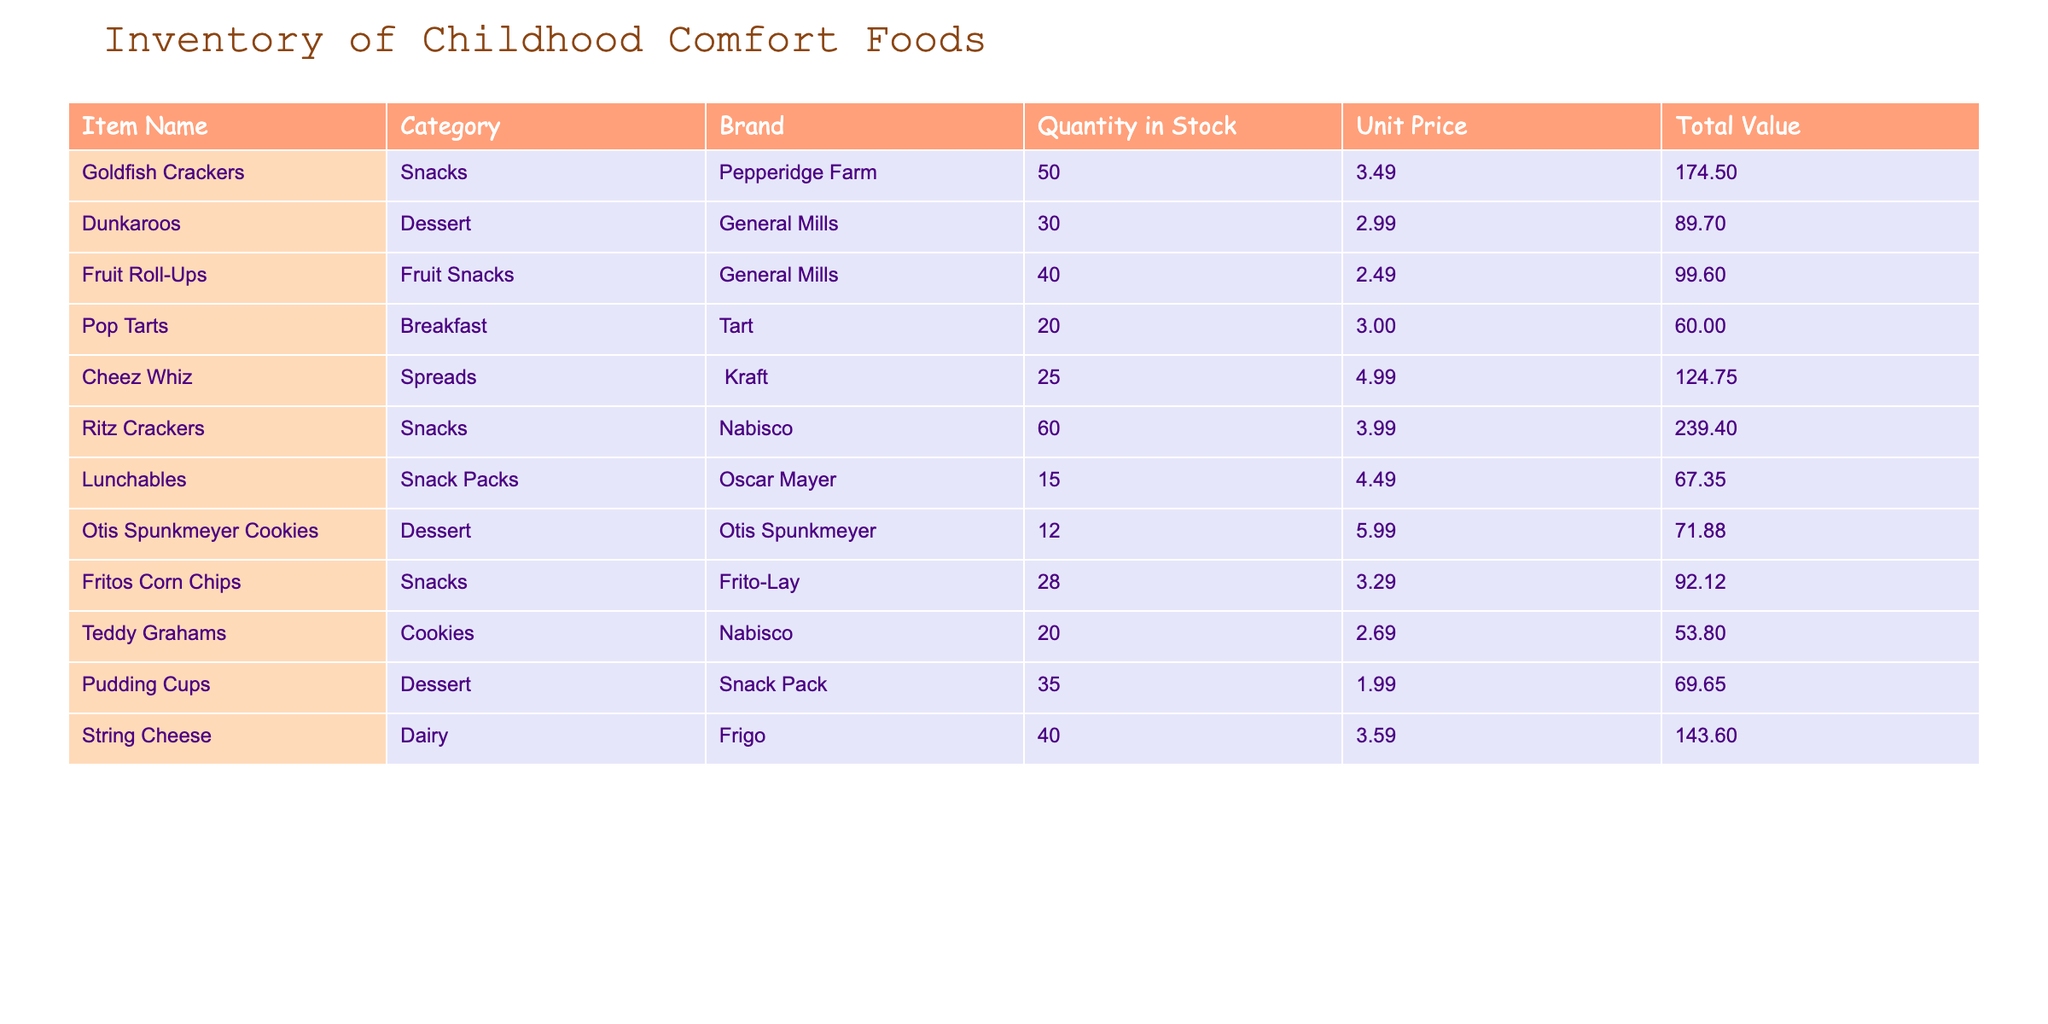What is the total quantity of Goldfish Crackers in stock? The table shows that the quantity of Goldfish Crackers is listed in the "Quantity in Stock" column, which indicates a total of 50 units.
Answer: 50 What is the unit price of Dunkaroos? Referring to the "Unit Price" column for Dunkaroos, the price is shown as $2.99.
Answer: $2.99 Which snacks have a quantity in stock greater than 40? We need to look at the "Quantity in Stock" for each snack. Goldfish Crackers (50), Ritz Crackers (60), Fruit Roll-Ups (40), and Fritos Corn Chips (28) are checked. Only Goldfish Crackers and Ritz Crackers meet the criteria with values over 40.
Answer: Goldfish Crackers, Ritz Crackers What is the total value of all the Dessert items combined? We identify the Dessert items as Dunkaroos, Otis Spunkmeyer Cookies, and Pudding Cups with values $89.70, $71.88, and $69.65, respectively. Summing these gives (89.70 + 71.88 + 69.65) = 231.23.
Answer: $231.23 Is there more than one item with a unit price of $3.00? In the table, we can see Pop Tarts have a unit price of $3.00. Checking the other items, we find that no other items share this exact price, confirming there’s only one such item.
Answer: No What is the average quantity in stock for all items? To find the average, we sum the quantities: (50 + 30 + 40 + 20 + 25 + 60 + 15 + 12 + 28 + 20 + 35 + 40) =  410. Dividing by the total number of items (12) gives us an average of 34.17.
Answer: 34.17 Which item has the highest total value? We compare the "Total Value" figures of all items. Ritz Crackers ($239.40) is the largest figure, while others are lower, confirming that Ritz Crackers have the highest total value.
Answer: Ritz Crackers Are there any spreads in stock? By looking through the "Category" column, we find one item categorized as Spread, which is Cheez Whiz. Thus, there is indeed a spread available in stock.
Answer: Yes What is the difference in total value between Ritz Crackers and Goldfish Crackers? The total value of Ritz Crackers is $239.40, and that of Goldfish Crackers is $174.50. The difference is calculated as ($239.40 - $174.50) = $64.90.
Answer: $64.90 